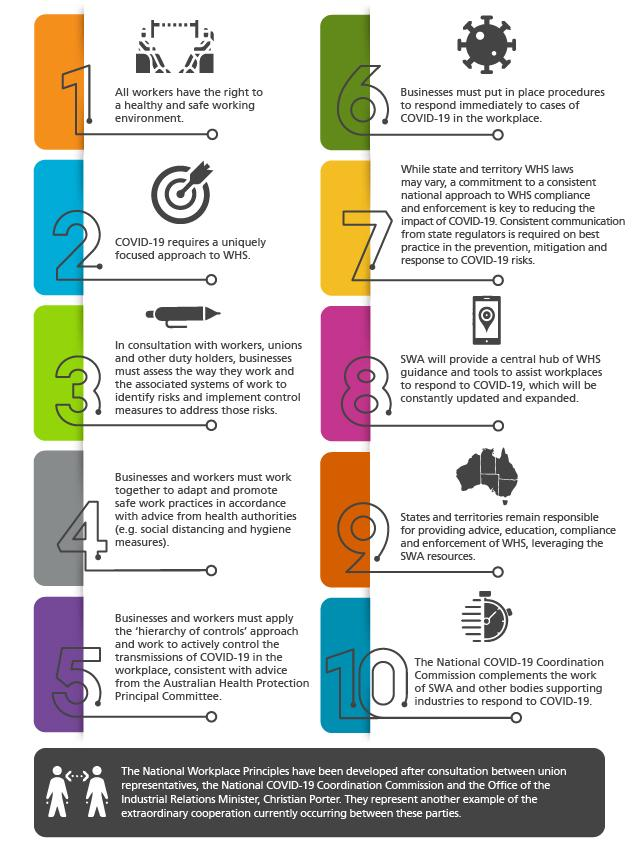Give some essential details in this illustration. The responsibility for providing advice, education, compliance, and enforcement of Work Health and Safety (WHS) lies with the states and territories. The South Western Sydney Local Health District will provide guidance and tools to assist workplaces in responding to COVID-19, in accordance with the South Western Sydney Guidance for Businesses and Organisations. At workplaces, it is essential to adopt social distancing and hygiene measures as per point 4 to ensure the safety and well-being of employees and visitors, and to prevent the spread of infectious diseases. It is important for state regulators to provide consistent communication about best practices in the prevention, mitigation, and response to COVID-19 risks. 